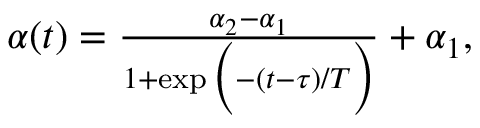Convert formula to latex. <formula><loc_0><loc_0><loc_500><loc_500>\begin{array} { r } { \alpha ( t ) = \frac { \alpha _ { 2 } - \alpha _ { 1 } } { 1 + \exp \left ( - ( t - \tau ) / T \right ) } + \alpha _ { 1 } , } \end{array}</formula> 